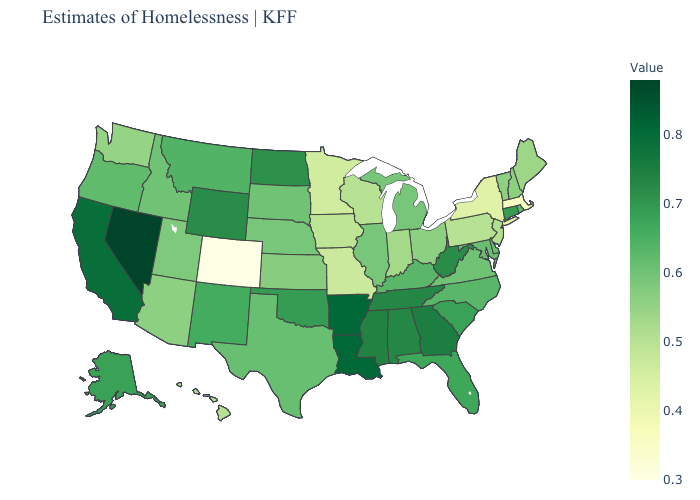Does Louisiana have the highest value in the South?
Be succinct. Yes. Among the states that border Oregon , does Washington have the highest value?
Keep it brief. No. Is the legend a continuous bar?
Answer briefly. Yes. Among the states that border Arkansas , which have the highest value?
Be succinct. Louisiana. 